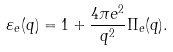Convert formula to latex. <formula><loc_0><loc_0><loc_500><loc_500>\varepsilon _ { e } ( q ) = 1 + \frac { 4 \pi e ^ { 2 } } { q ^ { 2 } } \Pi _ { e } ( q ) .</formula> 